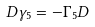Convert formula to latex. <formula><loc_0><loc_0><loc_500><loc_500>D \gamma _ { 5 } = - \Gamma _ { 5 } D</formula> 